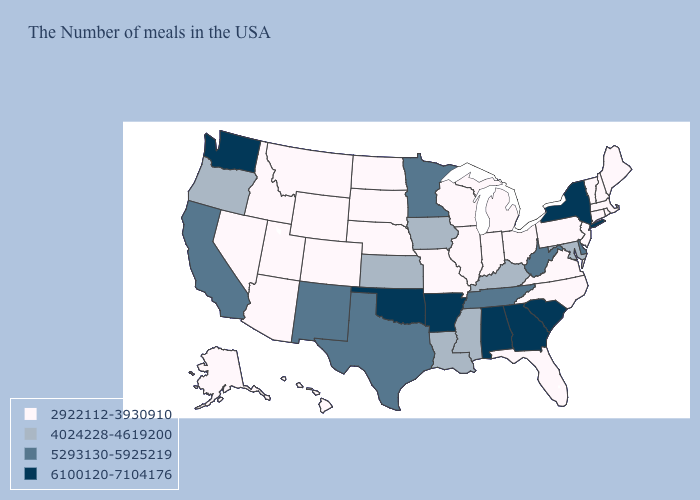What is the value of Iowa?
Concise answer only. 4024228-4619200. Which states have the lowest value in the MidWest?
Concise answer only. Ohio, Michigan, Indiana, Wisconsin, Illinois, Missouri, Nebraska, South Dakota, North Dakota. Does New York have the highest value in the USA?
Keep it brief. Yes. Which states have the lowest value in the USA?
Write a very short answer. Maine, Massachusetts, Rhode Island, New Hampshire, Vermont, Connecticut, New Jersey, Pennsylvania, Virginia, North Carolina, Ohio, Florida, Michigan, Indiana, Wisconsin, Illinois, Missouri, Nebraska, South Dakota, North Dakota, Wyoming, Colorado, Utah, Montana, Arizona, Idaho, Nevada, Alaska, Hawaii. Does Arkansas have the highest value in the USA?
Answer briefly. Yes. What is the lowest value in states that border Virginia?
Short answer required. 2922112-3930910. Which states hav the highest value in the MidWest?
Keep it brief. Minnesota. How many symbols are there in the legend?
Concise answer only. 4. Name the states that have a value in the range 2922112-3930910?
Keep it brief. Maine, Massachusetts, Rhode Island, New Hampshire, Vermont, Connecticut, New Jersey, Pennsylvania, Virginia, North Carolina, Ohio, Florida, Michigan, Indiana, Wisconsin, Illinois, Missouri, Nebraska, South Dakota, North Dakota, Wyoming, Colorado, Utah, Montana, Arizona, Idaho, Nevada, Alaska, Hawaii. What is the lowest value in the USA?
Answer briefly. 2922112-3930910. Which states have the highest value in the USA?
Keep it brief. New York, South Carolina, Georgia, Alabama, Arkansas, Oklahoma, Washington. How many symbols are there in the legend?
Keep it brief. 4. Does Idaho have the highest value in the USA?
Quick response, please. No. What is the value of West Virginia?
Answer briefly. 5293130-5925219. Which states have the lowest value in the USA?
Be succinct. Maine, Massachusetts, Rhode Island, New Hampshire, Vermont, Connecticut, New Jersey, Pennsylvania, Virginia, North Carolina, Ohio, Florida, Michigan, Indiana, Wisconsin, Illinois, Missouri, Nebraska, South Dakota, North Dakota, Wyoming, Colorado, Utah, Montana, Arizona, Idaho, Nevada, Alaska, Hawaii. 